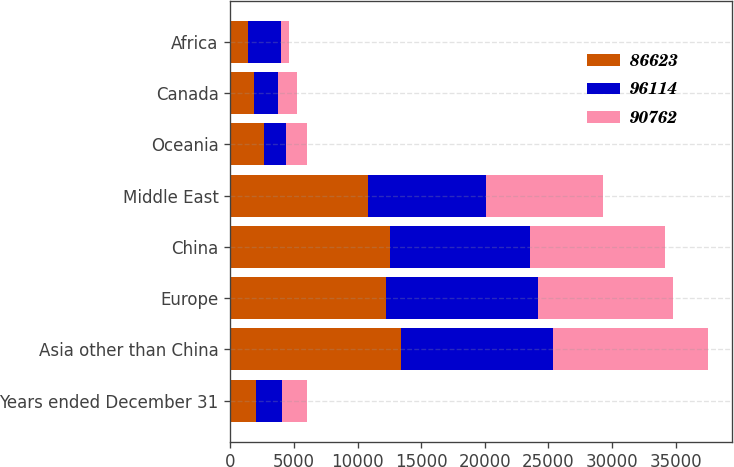Convert chart to OTSL. <chart><loc_0><loc_0><loc_500><loc_500><stacked_bar_chart><ecel><fcel>Years ended December 31<fcel>Asia other than China<fcel>Europe<fcel>China<fcel>Middle East<fcel>Oceania<fcel>Canada<fcel>Africa<nl><fcel>86623<fcel>2015<fcel>13433<fcel>12248<fcel>12556<fcel>10846<fcel>2601<fcel>1870<fcel>1398<nl><fcel>96114<fcel>2014<fcel>11900<fcel>11898<fcel>11029<fcel>9243<fcel>1757<fcel>1901<fcel>2596<nl><fcel>90762<fcel>2013<fcel>12200<fcel>10622<fcel>10555<fcel>9165<fcel>1657<fcel>1486<fcel>621<nl></chart> 